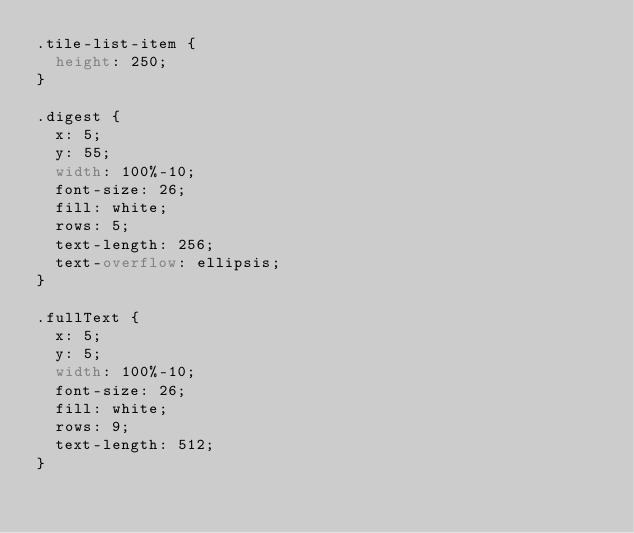<code> <loc_0><loc_0><loc_500><loc_500><_CSS_>.tile-list-item {
  height: 250;
}

.digest {
  x: 5;
  y: 55;
  width: 100%-10;
  font-size: 26;
  fill: white;
  rows: 5;
  text-length: 256;
  text-overflow: ellipsis;
}

.fullText {
  x: 5;
  y: 5;
  width: 100%-10;
  font-size: 26;
  fill: white;
  rows: 9;
  text-length: 512;
}
</code> 